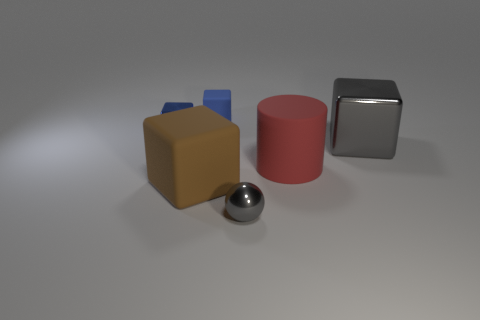The small object in front of the shiny object to the left of the small matte object is what shape?
Ensure brevity in your answer.  Sphere. Are there any other things that have the same color as the cylinder?
Offer a very short reply. No. There is a blue metallic thing; is its size the same as the gray object that is to the right of the tiny gray sphere?
Keep it short and to the point. No. What number of big objects are either gray blocks or purple metal balls?
Your response must be concise. 1. Is the number of big metallic objects greater than the number of big green matte things?
Offer a very short reply. Yes. There is a matte block in front of the small blue thing behind the blue metallic thing; what number of blue cubes are on the right side of it?
Your answer should be compact. 1. The big red matte object has what shape?
Provide a short and direct response. Cylinder. How many other objects are there of the same material as the ball?
Give a very brief answer. 2. Is the cylinder the same size as the brown thing?
Ensure brevity in your answer.  Yes. There is a tiny blue thing to the left of the brown cube; what shape is it?
Offer a terse response. Cube. 